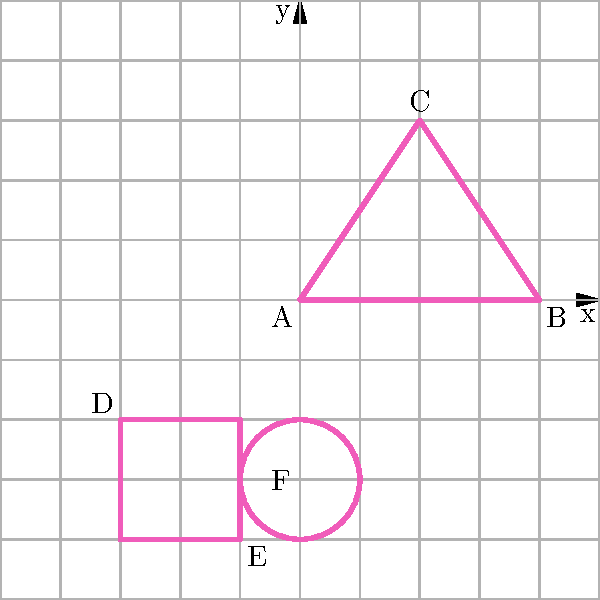As a synthwave music producer, you're designing a geometric album cover inspired by the genre's aesthetic. You've plotted three shapes on a coordinate plane: a triangle (ABC), a rectangle (with D and E as opposite corners), and a circle (centered at F). If the area of the triangle is 6 square units and the radius of the circle is 1 unit, what is the total area of all three shapes combined? Let's break this down step-by-step:

1. Area of the triangle ABC:
   We're given that the area is 6 square units.

2. Area of the rectangle:
   To find this, we need the width and height.
   Width = $|-3 - (-1)| = 2$ units
   Height = $|-2 - (-4)| = 2$ units
   Area of rectangle = $2 \times 2 = 4$ square units

3. Area of the circle:
   We're given that the radius is 1 unit.
   Area of circle = $\pi r^2 = \pi \times 1^2 = \pi$ square units

4. Total area:
   Sum of all three areas = Area of triangle + Area of rectangle + Area of circle
   $= 6 + 4 + \pi$ square units

5. Simplifying:
   $= 10 + \pi$ square units
Answer: $10 + \pi$ square units 